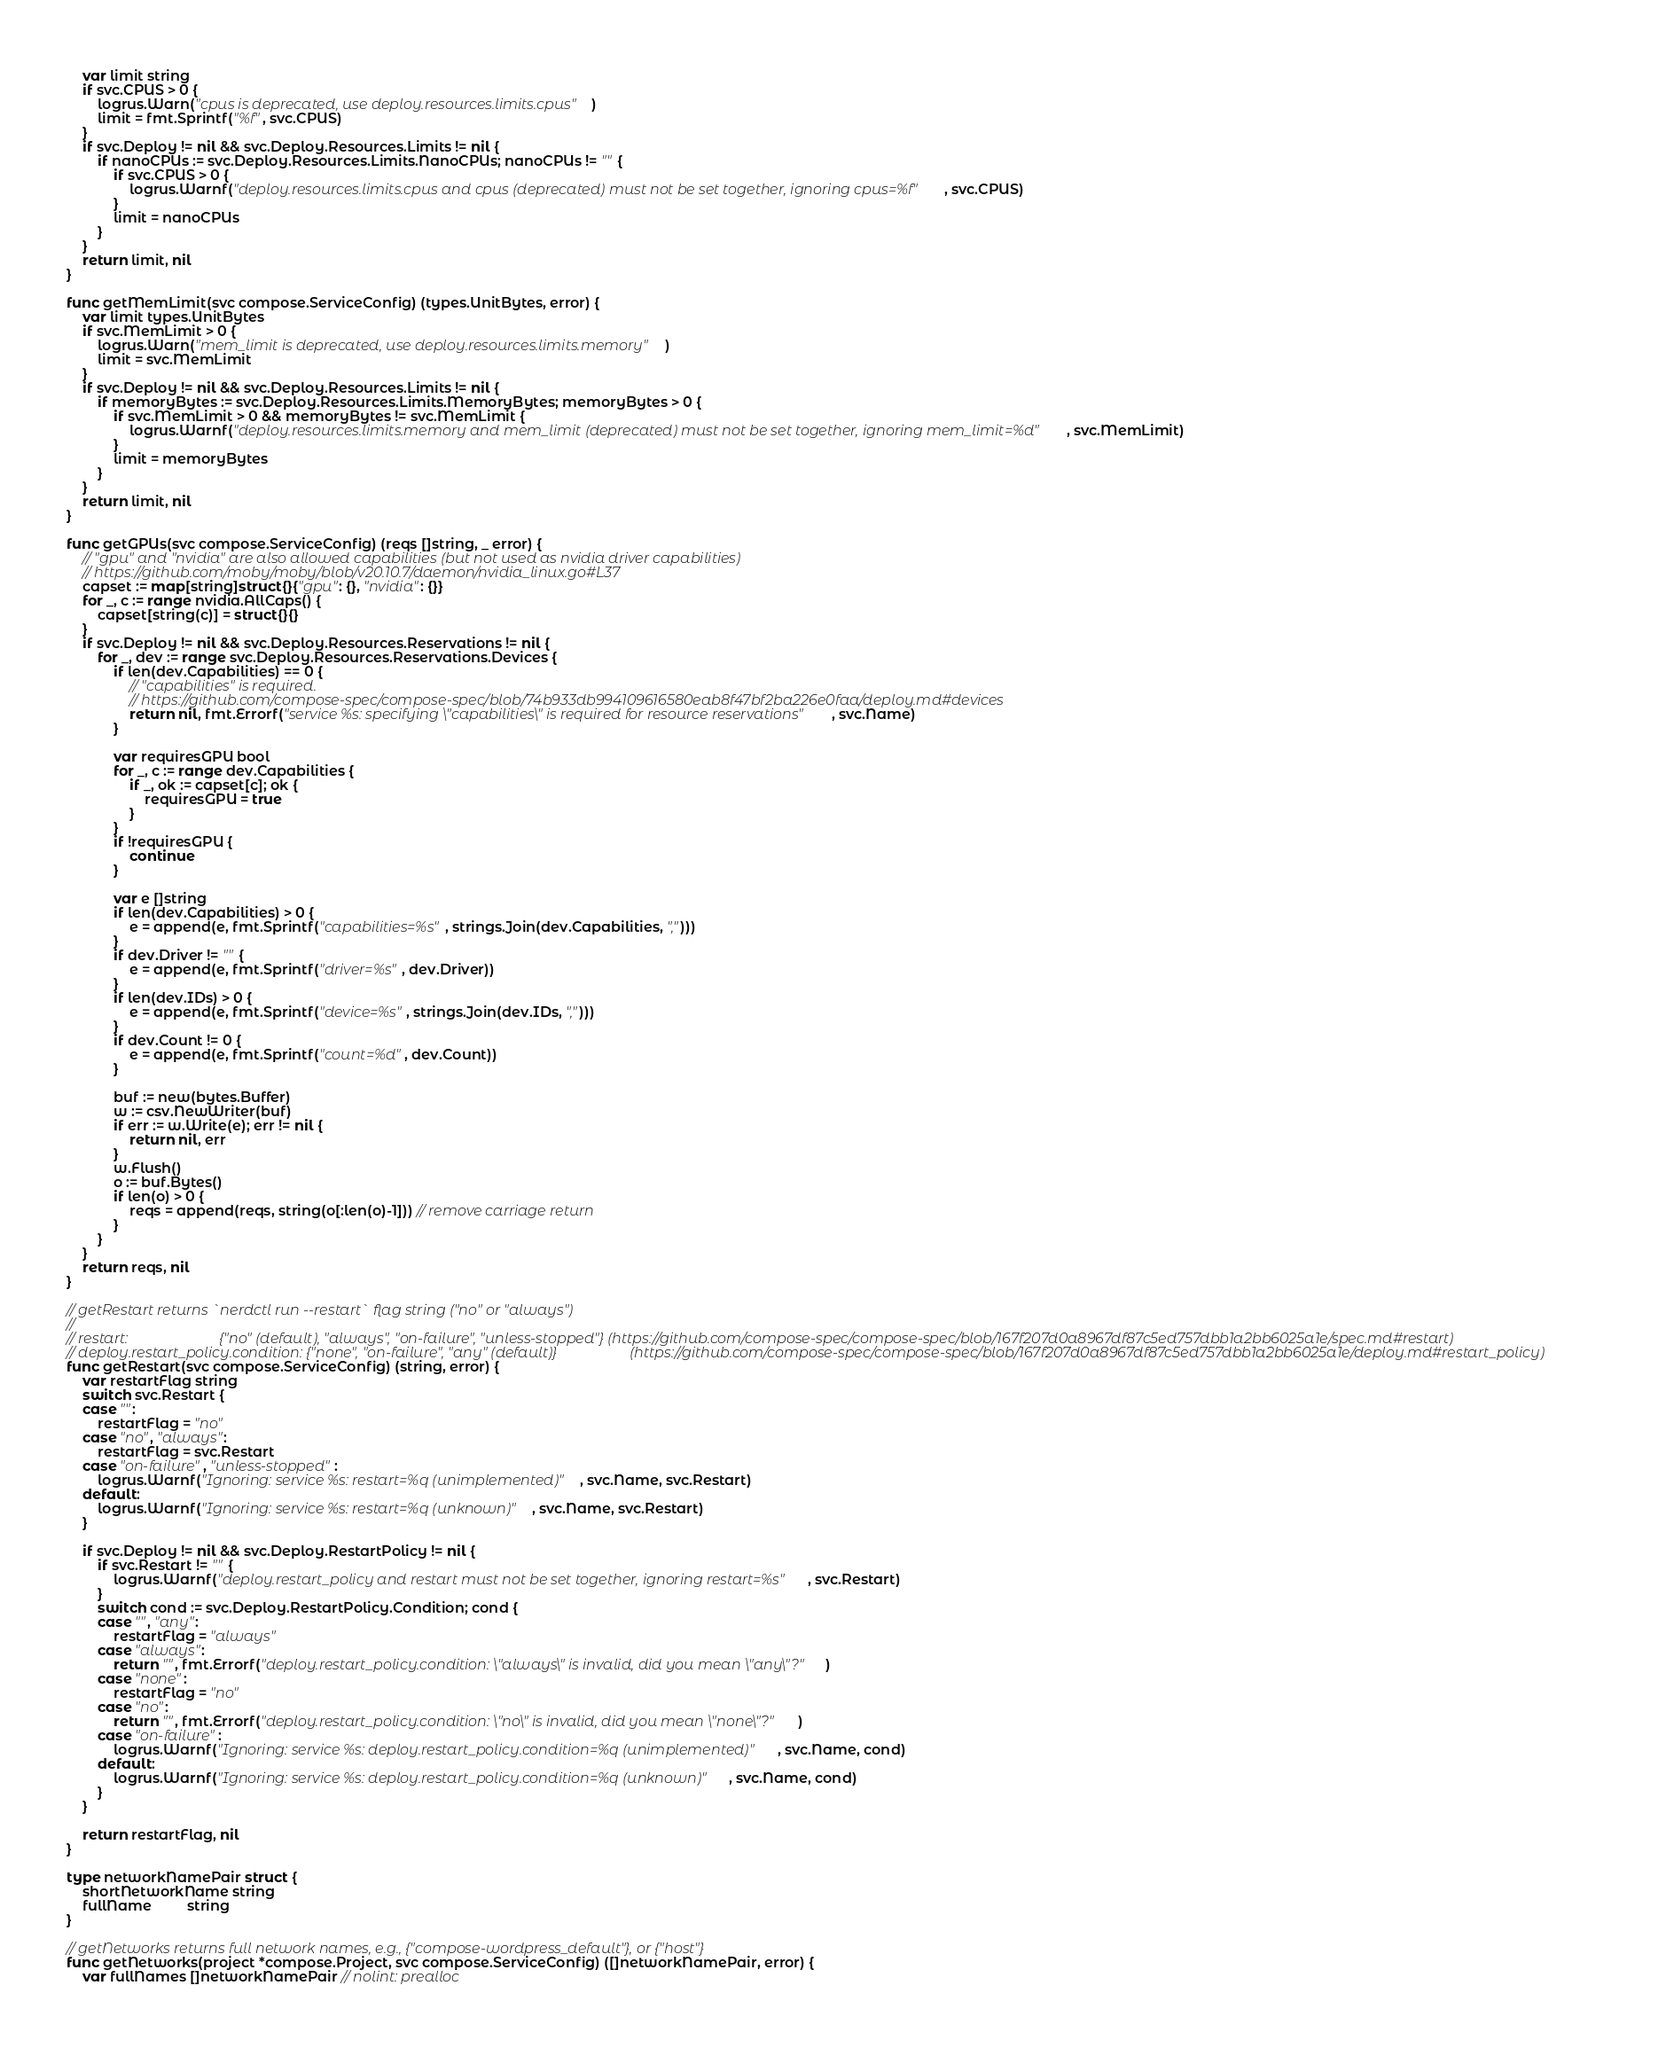<code> <loc_0><loc_0><loc_500><loc_500><_Go_>	var limit string
	if svc.CPUS > 0 {
		logrus.Warn("cpus is deprecated, use deploy.resources.limits.cpus")
		limit = fmt.Sprintf("%f", svc.CPUS)
	}
	if svc.Deploy != nil && svc.Deploy.Resources.Limits != nil {
		if nanoCPUs := svc.Deploy.Resources.Limits.NanoCPUs; nanoCPUs != "" {
			if svc.CPUS > 0 {
				logrus.Warnf("deploy.resources.limits.cpus and cpus (deprecated) must not be set together, ignoring cpus=%f", svc.CPUS)
			}
			limit = nanoCPUs
		}
	}
	return limit, nil
}

func getMemLimit(svc compose.ServiceConfig) (types.UnitBytes, error) {
	var limit types.UnitBytes
	if svc.MemLimit > 0 {
		logrus.Warn("mem_limit is deprecated, use deploy.resources.limits.memory")
		limit = svc.MemLimit
	}
	if svc.Deploy != nil && svc.Deploy.Resources.Limits != nil {
		if memoryBytes := svc.Deploy.Resources.Limits.MemoryBytes; memoryBytes > 0 {
			if svc.MemLimit > 0 && memoryBytes != svc.MemLimit {
				logrus.Warnf("deploy.resources.limits.memory and mem_limit (deprecated) must not be set together, ignoring mem_limit=%d", svc.MemLimit)
			}
			limit = memoryBytes
		}
	}
	return limit, nil
}

func getGPUs(svc compose.ServiceConfig) (reqs []string, _ error) {
	// "gpu" and "nvidia" are also allowed capabilities (but not used as nvidia driver capabilities)
	// https://github.com/moby/moby/blob/v20.10.7/daemon/nvidia_linux.go#L37
	capset := map[string]struct{}{"gpu": {}, "nvidia": {}}
	for _, c := range nvidia.AllCaps() {
		capset[string(c)] = struct{}{}
	}
	if svc.Deploy != nil && svc.Deploy.Resources.Reservations != nil {
		for _, dev := range svc.Deploy.Resources.Reservations.Devices {
			if len(dev.Capabilities) == 0 {
				// "capabilities" is required.
				// https://github.com/compose-spec/compose-spec/blob/74b933db994109616580eab8f47bf2ba226e0faa/deploy.md#devices
				return nil, fmt.Errorf("service %s: specifying \"capabilities\" is required for resource reservations", svc.Name)
			}

			var requiresGPU bool
			for _, c := range dev.Capabilities {
				if _, ok := capset[c]; ok {
					requiresGPU = true
				}
			}
			if !requiresGPU {
				continue
			}

			var e []string
			if len(dev.Capabilities) > 0 {
				e = append(e, fmt.Sprintf("capabilities=%s", strings.Join(dev.Capabilities, ",")))
			}
			if dev.Driver != "" {
				e = append(e, fmt.Sprintf("driver=%s", dev.Driver))
			}
			if len(dev.IDs) > 0 {
				e = append(e, fmt.Sprintf("device=%s", strings.Join(dev.IDs, ",")))
			}
			if dev.Count != 0 {
				e = append(e, fmt.Sprintf("count=%d", dev.Count))
			}

			buf := new(bytes.Buffer)
			w := csv.NewWriter(buf)
			if err := w.Write(e); err != nil {
				return nil, err
			}
			w.Flush()
			o := buf.Bytes()
			if len(o) > 0 {
				reqs = append(reqs, string(o[:len(o)-1])) // remove carriage return
			}
		}
	}
	return reqs, nil
}

// getRestart returns `nerdctl run --restart` flag string ("no" or "always")
//
// restart:                         {"no" (default), "always", "on-failure", "unless-stopped"} (https://github.com/compose-spec/compose-spec/blob/167f207d0a8967df87c5ed757dbb1a2bb6025a1e/spec.md#restart)
// deploy.restart_policy.condition: {"none", "on-failure", "any" (default)}                    (https://github.com/compose-spec/compose-spec/blob/167f207d0a8967df87c5ed757dbb1a2bb6025a1e/deploy.md#restart_policy)
func getRestart(svc compose.ServiceConfig) (string, error) {
	var restartFlag string
	switch svc.Restart {
	case "":
		restartFlag = "no"
	case "no", "always":
		restartFlag = svc.Restart
	case "on-failure", "unless-stopped":
		logrus.Warnf("Ignoring: service %s: restart=%q (unimplemented)", svc.Name, svc.Restart)
	default:
		logrus.Warnf("Ignoring: service %s: restart=%q (unknown)", svc.Name, svc.Restart)
	}

	if svc.Deploy != nil && svc.Deploy.RestartPolicy != nil {
		if svc.Restart != "" {
			logrus.Warnf("deploy.restart_policy and restart must not be set together, ignoring restart=%s", svc.Restart)
		}
		switch cond := svc.Deploy.RestartPolicy.Condition; cond {
		case "", "any":
			restartFlag = "always"
		case "always":
			return "", fmt.Errorf("deploy.restart_policy.condition: \"always\" is invalid, did you mean \"any\"?")
		case "none":
			restartFlag = "no"
		case "no":
			return "", fmt.Errorf("deploy.restart_policy.condition: \"no\" is invalid, did you mean \"none\"?")
		case "on-failure":
			logrus.Warnf("Ignoring: service %s: deploy.restart_policy.condition=%q (unimplemented)", svc.Name, cond)
		default:
			logrus.Warnf("Ignoring: service %s: deploy.restart_policy.condition=%q (unknown)", svc.Name, cond)
		}
	}

	return restartFlag, nil
}

type networkNamePair struct {
	shortNetworkName string
	fullName         string
}

// getNetworks returns full network names, e.g., {"compose-wordpress_default"}, or {"host"}
func getNetworks(project *compose.Project, svc compose.ServiceConfig) ([]networkNamePair, error) {
	var fullNames []networkNamePair // nolint: prealloc
</code> 